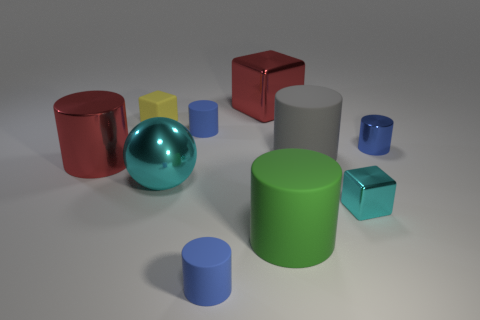Are there any other things that have the same shape as the big cyan metal thing?
Offer a terse response. No. What shape is the cyan shiny object that is the same size as the yellow object?
Your response must be concise. Cube. There is a tiny object that is in front of the tiny cyan metallic object; is its color the same as the small metallic cylinder?
Offer a terse response. Yes. How many things are matte things to the right of the small yellow rubber object or cyan shiny balls?
Offer a very short reply. 5. Are there more large red objects that are to the left of the big cyan thing than big green objects to the left of the big red shiny cylinder?
Offer a very short reply. Yes. Does the tiny cyan cube have the same material as the green object?
Your answer should be very brief. No. The object that is to the left of the big green object and in front of the shiny ball has what shape?
Your answer should be very brief. Cylinder. The tiny cyan object that is made of the same material as the big cyan ball is what shape?
Offer a terse response. Cube. Are there any tiny rubber objects?
Your answer should be very brief. Yes. Are there any small objects that are right of the block that is in front of the red shiny cylinder?
Provide a succinct answer. Yes. 